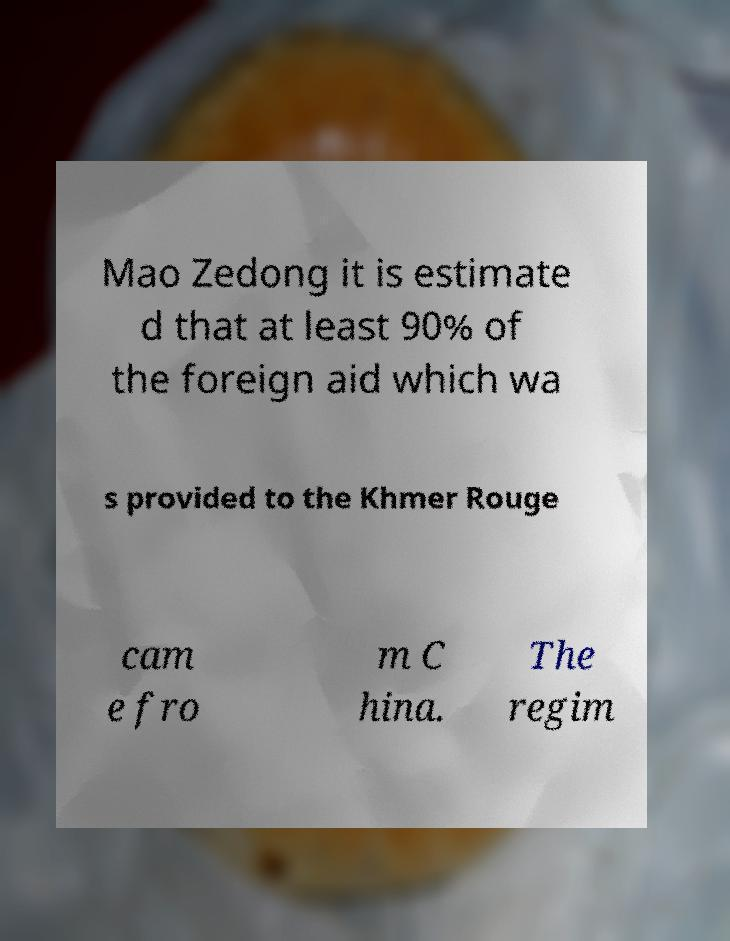Could you extract and type out the text from this image? Mao Zedong it is estimate d that at least 90% of the foreign aid which wa s provided to the Khmer Rouge cam e fro m C hina. The regim 